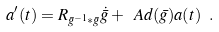Convert formula to latex. <formula><loc_0><loc_0><loc_500><loc_500>a ^ { \prime } ( t ) = R _ { \bar { g } ^ { - 1 } * \bar { g } } \dot { \bar { g } } + \ A d ( \bar { g } ) a ( t ) \ .</formula> 